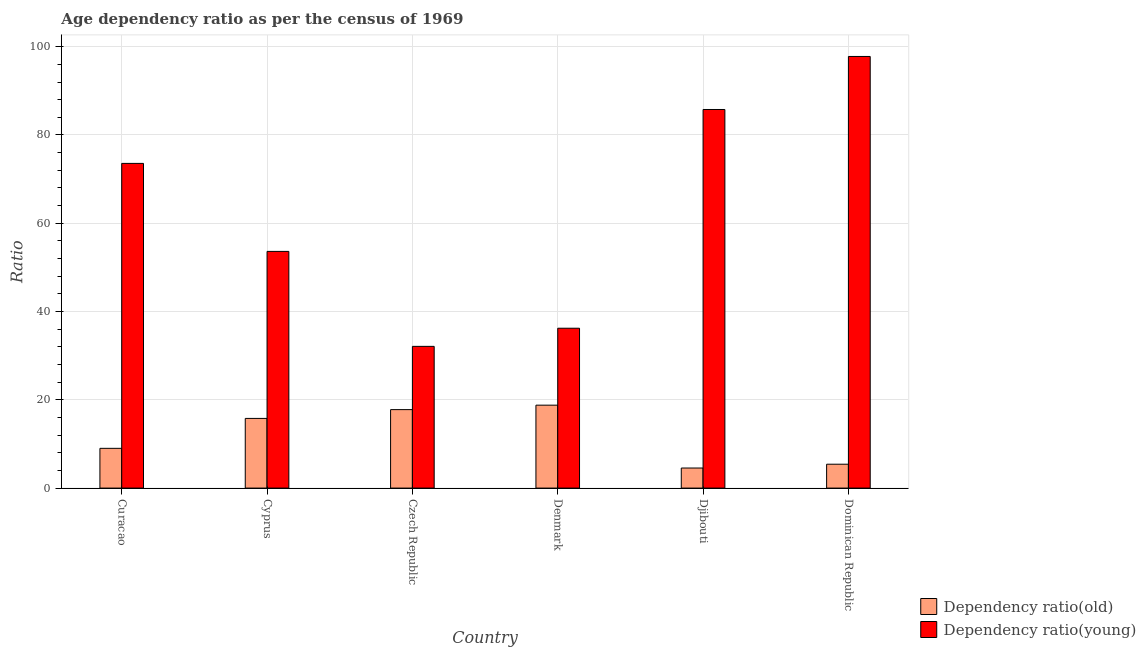How many different coloured bars are there?
Your answer should be compact. 2. Are the number of bars per tick equal to the number of legend labels?
Your answer should be very brief. Yes. Are the number of bars on each tick of the X-axis equal?
Offer a terse response. Yes. How many bars are there on the 4th tick from the left?
Offer a terse response. 2. What is the label of the 1st group of bars from the left?
Give a very brief answer. Curacao. In how many cases, is the number of bars for a given country not equal to the number of legend labels?
Make the answer very short. 0. What is the age dependency ratio(young) in Denmark?
Offer a very short reply. 36.22. Across all countries, what is the maximum age dependency ratio(young)?
Give a very brief answer. 97.79. Across all countries, what is the minimum age dependency ratio(young)?
Make the answer very short. 32.11. In which country was the age dependency ratio(young) maximum?
Provide a short and direct response. Dominican Republic. In which country was the age dependency ratio(old) minimum?
Your response must be concise. Djibouti. What is the total age dependency ratio(young) in the graph?
Offer a very short reply. 379.07. What is the difference between the age dependency ratio(young) in Denmark and that in Dominican Republic?
Give a very brief answer. -61.57. What is the difference between the age dependency ratio(young) in Dominican Republic and the age dependency ratio(old) in Czech Republic?
Keep it short and to the point. 80.01. What is the average age dependency ratio(young) per country?
Keep it short and to the point. 63.18. What is the difference between the age dependency ratio(old) and age dependency ratio(young) in Dominican Republic?
Your answer should be compact. -92.38. What is the ratio of the age dependency ratio(young) in Curacao to that in Cyprus?
Provide a succinct answer. 1.37. Is the age dependency ratio(old) in Czech Republic less than that in Djibouti?
Make the answer very short. No. Is the difference between the age dependency ratio(old) in Curacao and Denmark greater than the difference between the age dependency ratio(young) in Curacao and Denmark?
Provide a short and direct response. No. What is the difference between the highest and the second highest age dependency ratio(young)?
Give a very brief answer. 12.01. What is the difference between the highest and the lowest age dependency ratio(old)?
Provide a succinct answer. 14.24. In how many countries, is the age dependency ratio(old) greater than the average age dependency ratio(old) taken over all countries?
Provide a short and direct response. 3. Is the sum of the age dependency ratio(old) in Czech Republic and Djibouti greater than the maximum age dependency ratio(young) across all countries?
Keep it short and to the point. No. What does the 1st bar from the left in Curacao represents?
Your answer should be very brief. Dependency ratio(old). What does the 1st bar from the right in Curacao represents?
Give a very brief answer. Dependency ratio(young). How many bars are there?
Your answer should be very brief. 12. Are all the bars in the graph horizontal?
Give a very brief answer. No. How many countries are there in the graph?
Keep it short and to the point. 6. What is the difference between two consecutive major ticks on the Y-axis?
Give a very brief answer. 20. Are the values on the major ticks of Y-axis written in scientific E-notation?
Ensure brevity in your answer.  No. Does the graph contain any zero values?
Provide a short and direct response. No. Does the graph contain grids?
Give a very brief answer. Yes. How many legend labels are there?
Ensure brevity in your answer.  2. What is the title of the graph?
Ensure brevity in your answer.  Age dependency ratio as per the census of 1969. What is the label or title of the X-axis?
Make the answer very short. Country. What is the label or title of the Y-axis?
Your answer should be very brief. Ratio. What is the Ratio of Dependency ratio(old) in Curacao?
Provide a short and direct response. 9.01. What is the Ratio of Dependency ratio(young) in Curacao?
Your response must be concise. 73.56. What is the Ratio in Dependency ratio(old) in Cyprus?
Keep it short and to the point. 15.79. What is the Ratio of Dependency ratio(young) in Cyprus?
Keep it short and to the point. 53.62. What is the Ratio of Dependency ratio(old) in Czech Republic?
Make the answer very short. 17.78. What is the Ratio in Dependency ratio(young) in Czech Republic?
Provide a short and direct response. 32.11. What is the Ratio in Dependency ratio(old) in Denmark?
Give a very brief answer. 18.79. What is the Ratio in Dependency ratio(young) in Denmark?
Offer a terse response. 36.22. What is the Ratio in Dependency ratio(old) in Djibouti?
Give a very brief answer. 4.55. What is the Ratio in Dependency ratio(young) in Djibouti?
Your answer should be compact. 85.77. What is the Ratio in Dependency ratio(old) in Dominican Republic?
Provide a short and direct response. 5.41. What is the Ratio of Dependency ratio(young) in Dominican Republic?
Your answer should be compact. 97.79. Across all countries, what is the maximum Ratio in Dependency ratio(old)?
Make the answer very short. 18.79. Across all countries, what is the maximum Ratio of Dependency ratio(young)?
Make the answer very short. 97.79. Across all countries, what is the minimum Ratio in Dependency ratio(old)?
Keep it short and to the point. 4.55. Across all countries, what is the minimum Ratio of Dependency ratio(young)?
Keep it short and to the point. 32.11. What is the total Ratio in Dependency ratio(old) in the graph?
Give a very brief answer. 71.31. What is the total Ratio of Dependency ratio(young) in the graph?
Offer a very short reply. 379.07. What is the difference between the Ratio in Dependency ratio(old) in Curacao and that in Cyprus?
Provide a short and direct response. -6.78. What is the difference between the Ratio of Dependency ratio(young) in Curacao and that in Cyprus?
Ensure brevity in your answer.  19.94. What is the difference between the Ratio of Dependency ratio(old) in Curacao and that in Czech Republic?
Provide a succinct answer. -8.77. What is the difference between the Ratio of Dependency ratio(young) in Curacao and that in Czech Republic?
Your response must be concise. 41.45. What is the difference between the Ratio of Dependency ratio(old) in Curacao and that in Denmark?
Your answer should be very brief. -9.78. What is the difference between the Ratio in Dependency ratio(young) in Curacao and that in Denmark?
Make the answer very short. 37.34. What is the difference between the Ratio of Dependency ratio(old) in Curacao and that in Djibouti?
Your answer should be compact. 4.46. What is the difference between the Ratio of Dependency ratio(young) in Curacao and that in Djibouti?
Your answer should be very brief. -12.21. What is the difference between the Ratio of Dependency ratio(old) in Curacao and that in Dominican Republic?
Your answer should be compact. 3.59. What is the difference between the Ratio of Dependency ratio(young) in Curacao and that in Dominican Republic?
Give a very brief answer. -24.23. What is the difference between the Ratio in Dependency ratio(old) in Cyprus and that in Czech Republic?
Offer a very short reply. -1.99. What is the difference between the Ratio in Dependency ratio(young) in Cyprus and that in Czech Republic?
Your answer should be compact. 21.52. What is the difference between the Ratio of Dependency ratio(old) in Cyprus and that in Denmark?
Provide a short and direct response. -3. What is the difference between the Ratio of Dependency ratio(young) in Cyprus and that in Denmark?
Make the answer very short. 17.41. What is the difference between the Ratio in Dependency ratio(old) in Cyprus and that in Djibouti?
Provide a succinct answer. 11.24. What is the difference between the Ratio in Dependency ratio(young) in Cyprus and that in Djibouti?
Offer a very short reply. -32.15. What is the difference between the Ratio of Dependency ratio(old) in Cyprus and that in Dominican Republic?
Make the answer very short. 10.38. What is the difference between the Ratio of Dependency ratio(young) in Cyprus and that in Dominican Republic?
Keep it short and to the point. -44.16. What is the difference between the Ratio of Dependency ratio(old) in Czech Republic and that in Denmark?
Offer a terse response. -1.01. What is the difference between the Ratio in Dependency ratio(young) in Czech Republic and that in Denmark?
Provide a short and direct response. -4.11. What is the difference between the Ratio in Dependency ratio(old) in Czech Republic and that in Djibouti?
Provide a succinct answer. 13.23. What is the difference between the Ratio in Dependency ratio(young) in Czech Republic and that in Djibouti?
Your response must be concise. -53.67. What is the difference between the Ratio of Dependency ratio(old) in Czech Republic and that in Dominican Republic?
Offer a very short reply. 12.37. What is the difference between the Ratio in Dependency ratio(young) in Czech Republic and that in Dominican Republic?
Your answer should be very brief. -65.68. What is the difference between the Ratio in Dependency ratio(old) in Denmark and that in Djibouti?
Ensure brevity in your answer.  14.24. What is the difference between the Ratio in Dependency ratio(young) in Denmark and that in Djibouti?
Give a very brief answer. -49.56. What is the difference between the Ratio in Dependency ratio(old) in Denmark and that in Dominican Republic?
Provide a short and direct response. 13.38. What is the difference between the Ratio of Dependency ratio(young) in Denmark and that in Dominican Republic?
Your answer should be very brief. -61.57. What is the difference between the Ratio in Dependency ratio(old) in Djibouti and that in Dominican Republic?
Offer a terse response. -0.87. What is the difference between the Ratio in Dependency ratio(young) in Djibouti and that in Dominican Republic?
Your response must be concise. -12.01. What is the difference between the Ratio of Dependency ratio(old) in Curacao and the Ratio of Dependency ratio(young) in Cyprus?
Your answer should be very brief. -44.62. What is the difference between the Ratio in Dependency ratio(old) in Curacao and the Ratio in Dependency ratio(young) in Czech Republic?
Provide a succinct answer. -23.1. What is the difference between the Ratio in Dependency ratio(old) in Curacao and the Ratio in Dependency ratio(young) in Denmark?
Offer a terse response. -27.21. What is the difference between the Ratio of Dependency ratio(old) in Curacao and the Ratio of Dependency ratio(young) in Djibouti?
Your answer should be very brief. -76.77. What is the difference between the Ratio in Dependency ratio(old) in Curacao and the Ratio in Dependency ratio(young) in Dominican Republic?
Your response must be concise. -88.78. What is the difference between the Ratio of Dependency ratio(old) in Cyprus and the Ratio of Dependency ratio(young) in Czech Republic?
Offer a terse response. -16.32. What is the difference between the Ratio of Dependency ratio(old) in Cyprus and the Ratio of Dependency ratio(young) in Denmark?
Ensure brevity in your answer.  -20.43. What is the difference between the Ratio of Dependency ratio(old) in Cyprus and the Ratio of Dependency ratio(young) in Djibouti?
Ensure brevity in your answer.  -69.99. What is the difference between the Ratio in Dependency ratio(old) in Cyprus and the Ratio in Dependency ratio(young) in Dominican Republic?
Your answer should be compact. -82. What is the difference between the Ratio in Dependency ratio(old) in Czech Republic and the Ratio in Dependency ratio(young) in Denmark?
Provide a succinct answer. -18.44. What is the difference between the Ratio in Dependency ratio(old) in Czech Republic and the Ratio in Dependency ratio(young) in Djibouti?
Your answer should be very brief. -67.99. What is the difference between the Ratio in Dependency ratio(old) in Czech Republic and the Ratio in Dependency ratio(young) in Dominican Republic?
Provide a succinct answer. -80.01. What is the difference between the Ratio in Dependency ratio(old) in Denmark and the Ratio in Dependency ratio(young) in Djibouti?
Your answer should be very brief. -66.99. What is the difference between the Ratio in Dependency ratio(old) in Denmark and the Ratio in Dependency ratio(young) in Dominican Republic?
Make the answer very short. -79. What is the difference between the Ratio in Dependency ratio(old) in Djibouti and the Ratio in Dependency ratio(young) in Dominican Republic?
Your answer should be compact. -93.24. What is the average Ratio in Dependency ratio(old) per country?
Your answer should be very brief. 11.89. What is the average Ratio in Dependency ratio(young) per country?
Make the answer very short. 63.18. What is the difference between the Ratio in Dependency ratio(old) and Ratio in Dependency ratio(young) in Curacao?
Your answer should be very brief. -64.55. What is the difference between the Ratio of Dependency ratio(old) and Ratio of Dependency ratio(young) in Cyprus?
Your response must be concise. -37.84. What is the difference between the Ratio of Dependency ratio(old) and Ratio of Dependency ratio(young) in Czech Republic?
Provide a short and direct response. -14.33. What is the difference between the Ratio of Dependency ratio(old) and Ratio of Dependency ratio(young) in Denmark?
Ensure brevity in your answer.  -17.43. What is the difference between the Ratio in Dependency ratio(old) and Ratio in Dependency ratio(young) in Djibouti?
Your answer should be compact. -81.23. What is the difference between the Ratio of Dependency ratio(old) and Ratio of Dependency ratio(young) in Dominican Republic?
Offer a terse response. -92.38. What is the ratio of the Ratio in Dependency ratio(old) in Curacao to that in Cyprus?
Keep it short and to the point. 0.57. What is the ratio of the Ratio in Dependency ratio(young) in Curacao to that in Cyprus?
Make the answer very short. 1.37. What is the ratio of the Ratio in Dependency ratio(old) in Curacao to that in Czech Republic?
Your response must be concise. 0.51. What is the ratio of the Ratio of Dependency ratio(young) in Curacao to that in Czech Republic?
Provide a succinct answer. 2.29. What is the ratio of the Ratio of Dependency ratio(old) in Curacao to that in Denmark?
Your answer should be compact. 0.48. What is the ratio of the Ratio in Dependency ratio(young) in Curacao to that in Denmark?
Your answer should be very brief. 2.03. What is the ratio of the Ratio in Dependency ratio(old) in Curacao to that in Djibouti?
Your answer should be very brief. 1.98. What is the ratio of the Ratio in Dependency ratio(young) in Curacao to that in Djibouti?
Your answer should be compact. 0.86. What is the ratio of the Ratio in Dependency ratio(old) in Curacao to that in Dominican Republic?
Your response must be concise. 1.66. What is the ratio of the Ratio in Dependency ratio(young) in Curacao to that in Dominican Republic?
Offer a very short reply. 0.75. What is the ratio of the Ratio in Dependency ratio(old) in Cyprus to that in Czech Republic?
Offer a terse response. 0.89. What is the ratio of the Ratio in Dependency ratio(young) in Cyprus to that in Czech Republic?
Ensure brevity in your answer.  1.67. What is the ratio of the Ratio in Dependency ratio(old) in Cyprus to that in Denmark?
Ensure brevity in your answer.  0.84. What is the ratio of the Ratio of Dependency ratio(young) in Cyprus to that in Denmark?
Offer a very short reply. 1.48. What is the ratio of the Ratio of Dependency ratio(old) in Cyprus to that in Djibouti?
Offer a terse response. 3.47. What is the ratio of the Ratio of Dependency ratio(young) in Cyprus to that in Djibouti?
Provide a succinct answer. 0.63. What is the ratio of the Ratio of Dependency ratio(old) in Cyprus to that in Dominican Republic?
Provide a succinct answer. 2.92. What is the ratio of the Ratio in Dependency ratio(young) in Cyprus to that in Dominican Republic?
Offer a very short reply. 0.55. What is the ratio of the Ratio in Dependency ratio(old) in Czech Republic to that in Denmark?
Offer a terse response. 0.95. What is the ratio of the Ratio in Dependency ratio(young) in Czech Republic to that in Denmark?
Offer a very short reply. 0.89. What is the ratio of the Ratio in Dependency ratio(old) in Czech Republic to that in Djibouti?
Your answer should be compact. 3.91. What is the ratio of the Ratio in Dependency ratio(young) in Czech Republic to that in Djibouti?
Your answer should be compact. 0.37. What is the ratio of the Ratio of Dependency ratio(old) in Czech Republic to that in Dominican Republic?
Your answer should be very brief. 3.29. What is the ratio of the Ratio in Dependency ratio(young) in Czech Republic to that in Dominican Republic?
Provide a succinct answer. 0.33. What is the ratio of the Ratio of Dependency ratio(old) in Denmark to that in Djibouti?
Offer a terse response. 4.13. What is the ratio of the Ratio in Dependency ratio(young) in Denmark to that in Djibouti?
Your answer should be compact. 0.42. What is the ratio of the Ratio in Dependency ratio(old) in Denmark to that in Dominican Republic?
Provide a short and direct response. 3.47. What is the ratio of the Ratio of Dependency ratio(young) in Denmark to that in Dominican Republic?
Give a very brief answer. 0.37. What is the ratio of the Ratio of Dependency ratio(old) in Djibouti to that in Dominican Republic?
Give a very brief answer. 0.84. What is the ratio of the Ratio of Dependency ratio(young) in Djibouti to that in Dominican Republic?
Ensure brevity in your answer.  0.88. What is the difference between the highest and the second highest Ratio in Dependency ratio(old)?
Make the answer very short. 1.01. What is the difference between the highest and the second highest Ratio in Dependency ratio(young)?
Provide a succinct answer. 12.01. What is the difference between the highest and the lowest Ratio of Dependency ratio(old)?
Offer a terse response. 14.24. What is the difference between the highest and the lowest Ratio of Dependency ratio(young)?
Your answer should be very brief. 65.68. 